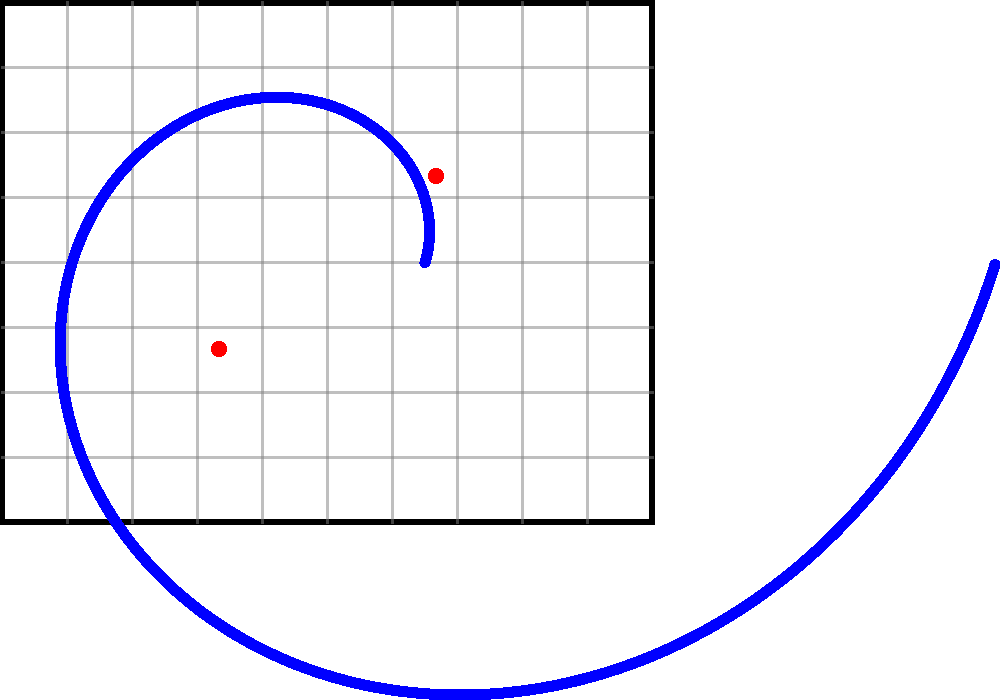Analyze the composition of this artwork using the grid overlay. What principle of design is prominently illustrated by the blue curve, and how does it relate to the red focal points? 1. Observe the blue curve: It forms a spiral shape reminiscent of the golden spiral, a common compositional tool in art.

2. Notice the grid: The canvas is divided into a 10x8 grid, helping to analyze proportions and placement.

3. Identify the red dots: These represent two focal points in the composition, placed at approximately (3.33, 2.67) and (6.67, 5.33) on the grid.

4. Analyze the relationship between the spiral and focal points:
   a. The spiral passes through or near both focal points.
   b. It creates a visual flow connecting these important areas of the composition.

5. Recognize the principle of design: The spiral illustrates the principle of movement or flow in the composition.

6. Understand the purpose: This curved path guides the viewer's eye through the artwork, connecting key elements (focal points) in a harmonious and dynamic way.

7. Relate to the Golden Ratio: The spiral's shape is reminiscent of the Golden Spiral, which is often associated with aesthetic appeal and balance in art.

8. Consider the artist's intent: By using this composition, the artist creates a sense of visual harmony and guides the viewer's attention in a specific pattern through the artwork.
Answer: Movement; guides viewer through focal points 